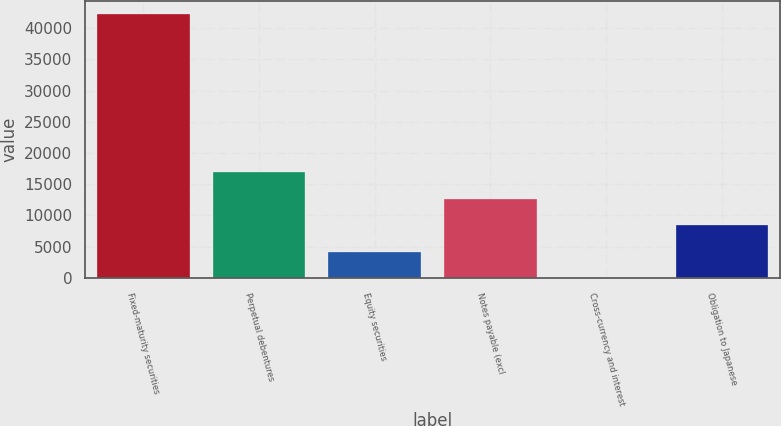<chart> <loc_0><loc_0><loc_500><loc_500><bar_chart><fcel>Fixed-maturity securities<fcel>Perpetual debentures<fcel>Equity securities<fcel>Notes payable (excl<fcel>Cross-currency and interest<fcel>Obligation to Japanese<nl><fcel>42288<fcel>16919.4<fcel>4235.1<fcel>12691.3<fcel>7<fcel>8463.2<nl></chart> 